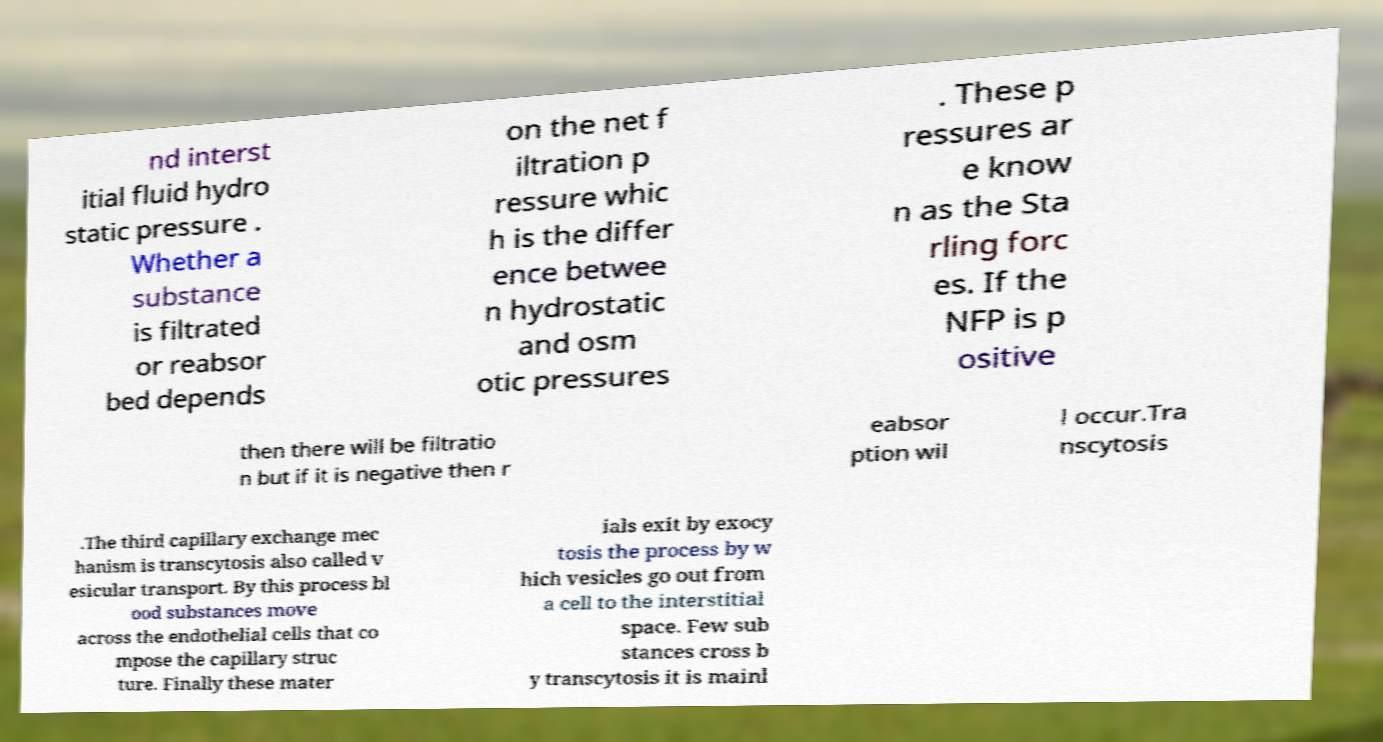Could you assist in decoding the text presented in this image and type it out clearly? nd interst itial fluid hydro static pressure . Whether a substance is filtrated or reabsor bed depends on the net f iltration p ressure whic h is the differ ence betwee n hydrostatic and osm otic pressures . These p ressures ar e know n as the Sta rling forc es. If the NFP is p ositive then there will be filtratio n but if it is negative then r eabsor ption wil l occur.Tra nscytosis .The third capillary exchange mec hanism is transcytosis also called v esicular transport. By this process bl ood substances move across the endothelial cells that co mpose the capillary struc ture. Finally these mater ials exit by exocy tosis the process by w hich vesicles go out from a cell to the interstitial space. Few sub stances cross b y transcytosis it is mainl 